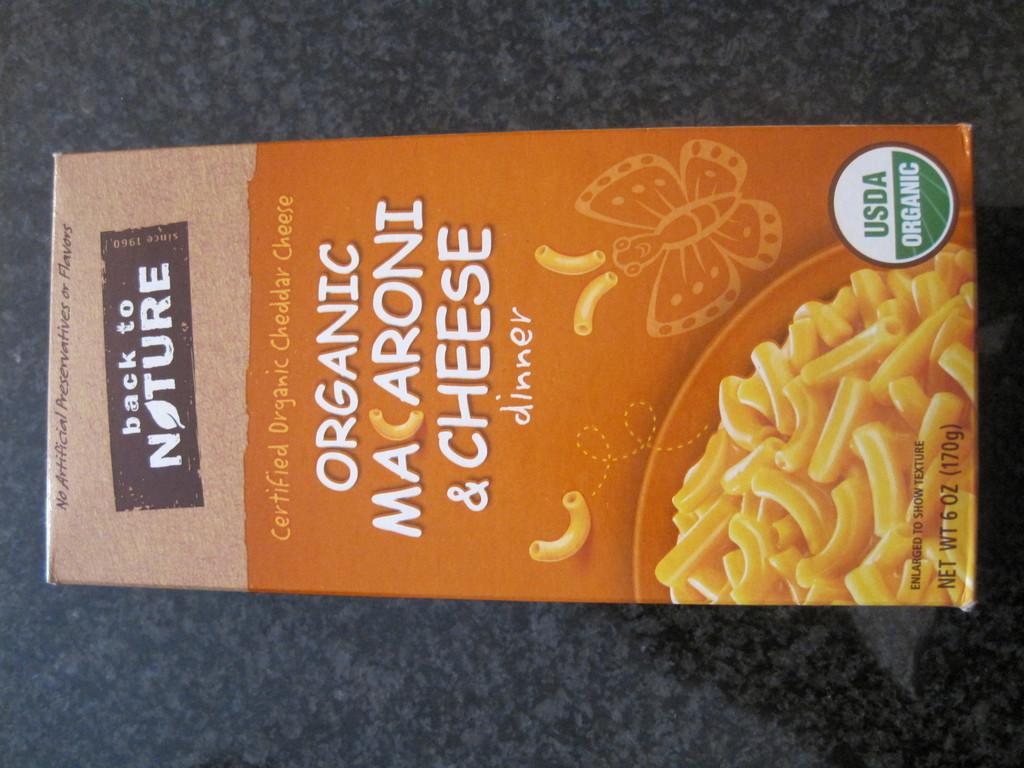What does the brand here claim to be going back to?
Keep it short and to the point. Nature. Its the macaroni and cheese organic?
Keep it short and to the point. Yes. 